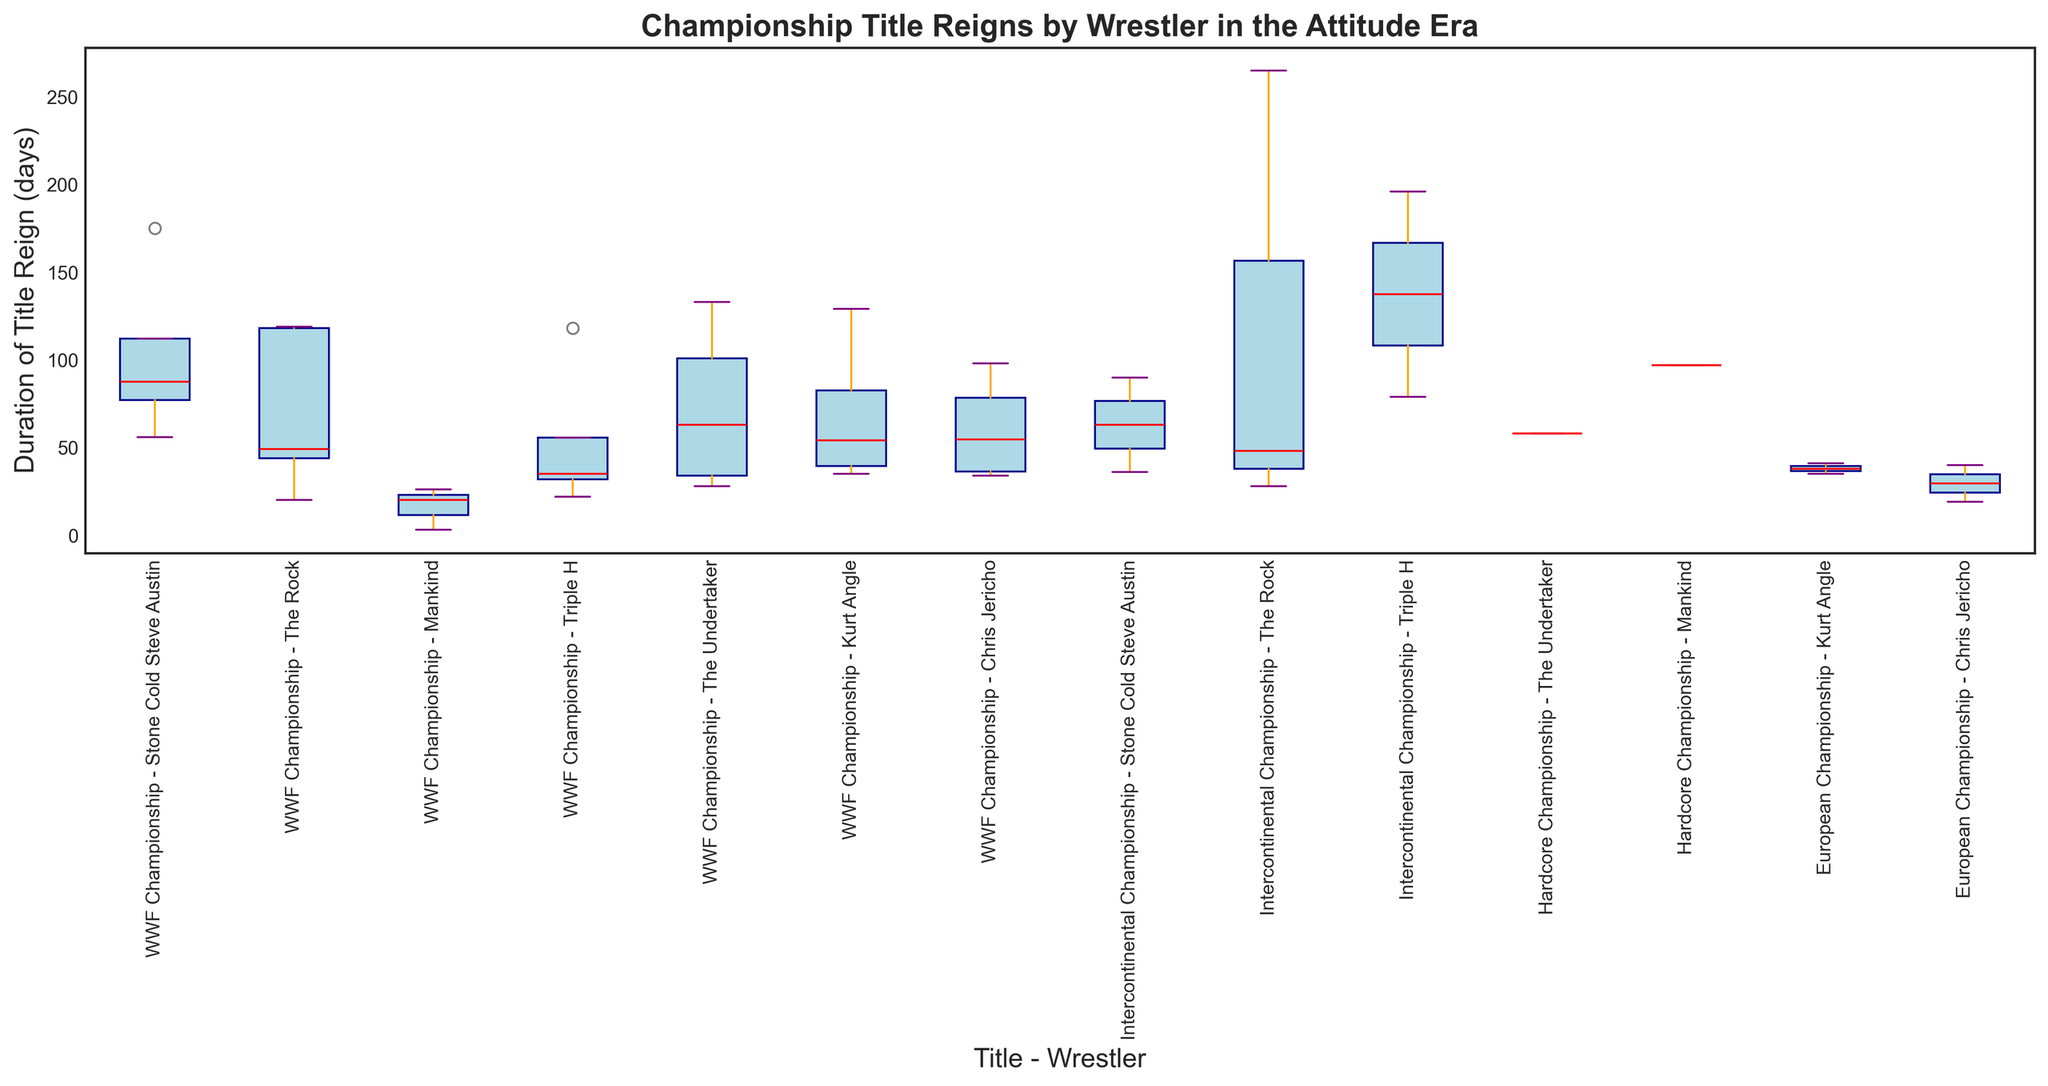Which wrestler has the longest median duration of a title reign for the WWF Championship? To determine the median duration, observe the red lines inside each box for the WWF Championship title reigns. The Undertaker’s median values are the highest compared to other wrestlers who held the WWF Championship.
Answer: The Undertaker Compare the interquartile range (IQR) of title reigns between The Rock and Kurt Angle for the WWF Championship. Who has the larger IQR? The IQR is the length of the boxplot from the lower quartile (25th percentile) to the upper quartile (75th percentile). Comparing both, The Rock’s WWF Championship boxplot spans a wider range than Kurt Angle's, indicating a larger IQR.
Answer: The Rock For which championship title does Triple H have his longest reign, and how many days was it? By checking the boxplots associated with Triple H, you can see that the Intercontinental Championship has an outer marker farthest to the right, representing the longest reign of 196 days.
Answer: Intercontinental Championship, 196 days Which wrestler has the title reign distributed the most widely for the Intercontinental Championship? Length of whiskers and the distance between the box edges indicate the spread. The Rock’s boxplot is taller and has longer whiskers, indicating a wider distribution for the Intercontinental Championship.
Answer: The Rock Identify the minimum duration of Mankind's title reign for the Hardcore Championship and compare it to his minimum duration for the WWF Championship reigns. Which is shorter? Look for the leftmost points on the Mankind's boxplots for both championships. For the WWF Championship, the minimum is 3 days, while for the Hardcore Championship, the minimum is 97. Thus, the shorter duration is for the WWF Championship.
Answer: WWF Championship Which title-wrestler combination has the smallest median duration, and what is that duration? Find the combination with the lowest red line inside the box. Mankind for the WWF Championship has the lowest median value, which is close to the bottom whisker.
Answer: Mankind, WWF Championship For the European Championship, compare Kurt Angle's median reign duration to Chris Jericho's median reign duration. Who had a longer median reign? Examine the red lines in the boxplots under the European Championship title for both Kurt Angle and Chris Jericho. Kurt Angle has a higher median line compared to Chris Jericho.
Answer: Kurt Angle How does the variation in duration for Chris Jericho's WWF Championship reigns compare to The Rock's reigns for the same title? Compare the heights of the boxes (interquartile range) and the lengths of whiskers. The Rock's boxplot spans a larger range and has longer whiskers than Chris Jericho’s WWF Championship reigns, indicating more variation.
Answer: The Rock What is the difference between the longest and shortest reigns for Stone Cold Steve Austin in the WWF Championship? Identify the longest and shortest points (whiskers) for Stone Cold Steve Austin’s boxplot in the WWF Championship and calculate the difference: 175 days (longest) - 56 days (shortest) = 119 days.
Answer: 119 days Which combination has the most outliers, and how many outliers does it have? Outliers are represented by dots outside the whiskers. By inspecting closely, The Rock for the Intercontinental Championship has the most outliers (green dots), with a total of 2 outliers.
Answer: The Rock, Intercontinental Championship, 2 outliers 